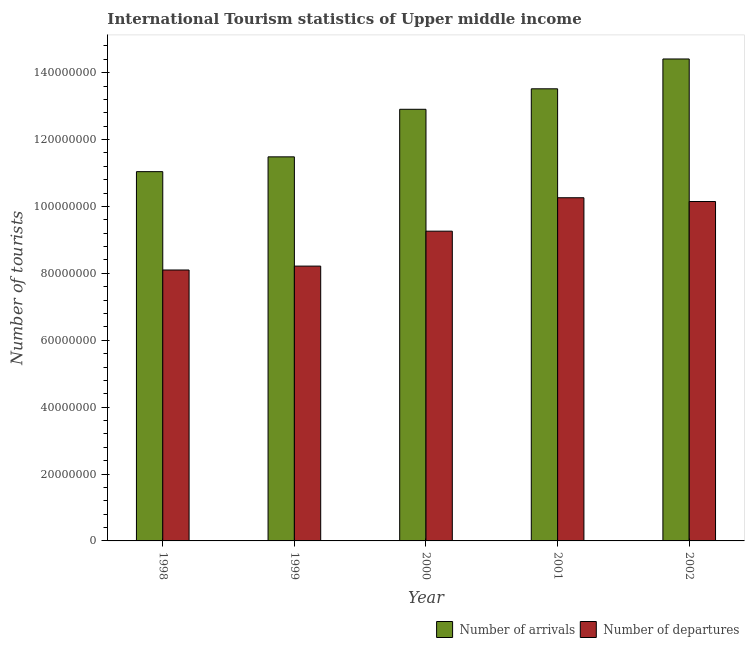How many groups of bars are there?
Keep it short and to the point. 5. Are the number of bars per tick equal to the number of legend labels?
Give a very brief answer. Yes. How many bars are there on the 5th tick from the right?
Ensure brevity in your answer.  2. What is the label of the 3rd group of bars from the left?
Give a very brief answer. 2000. What is the number of tourist departures in 2001?
Keep it short and to the point. 1.03e+08. Across all years, what is the maximum number of tourist departures?
Give a very brief answer. 1.03e+08. Across all years, what is the minimum number of tourist departures?
Provide a succinct answer. 8.10e+07. In which year was the number of tourist arrivals minimum?
Give a very brief answer. 1998. What is the total number of tourist arrivals in the graph?
Your answer should be very brief. 6.34e+08. What is the difference between the number of tourist departures in 2000 and that in 2001?
Give a very brief answer. -9.99e+06. What is the difference between the number of tourist arrivals in 2000 and the number of tourist departures in 2001?
Provide a short and direct response. -6.12e+06. What is the average number of tourist arrivals per year?
Offer a very short reply. 1.27e+08. In the year 2002, what is the difference between the number of tourist arrivals and number of tourist departures?
Ensure brevity in your answer.  0. In how many years, is the number of tourist arrivals greater than 44000000?
Give a very brief answer. 5. What is the ratio of the number of tourist arrivals in 1999 to that in 2000?
Make the answer very short. 0.89. Is the number of tourist arrivals in 2000 less than that in 2001?
Your response must be concise. Yes. Is the difference between the number of tourist arrivals in 1998 and 1999 greater than the difference between the number of tourist departures in 1998 and 1999?
Provide a succinct answer. No. What is the difference between the highest and the second highest number of tourist arrivals?
Give a very brief answer. 8.92e+06. What is the difference between the highest and the lowest number of tourist arrivals?
Your answer should be compact. 3.37e+07. What does the 1st bar from the left in 2001 represents?
Ensure brevity in your answer.  Number of arrivals. What does the 2nd bar from the right in 2002 represents?
Your response must be concise. Number of arrivals. How many bars are there?
Ensure brevity in your answer.  10. Are the values on the major ticks of Y-axis written in scientific E-notation?
Offer a very short reply. No. Does the graph contain grids?
Offer a very short reply. No. Where does the legend appear in the graph?
Your response must be concise. Bottom right. How are the legend labels stacked?
Keep it short and to the point. Horizontal. What is the title of the graph?
Your answer should be very brief. International Tourism statistics of Upper middle income. What is the label or title of the X-axis?
Your answer should be very brief. Year. What is the label or title of the Y-axis?
Ensure brevity in your answer.  Number of tourists. What is the Number of tourists in Number of arrivals in 1998?
Ensure brevity in your answer.  1.10e+08. What is the Number of tourists in Number of departures in 1998?
Offer a very short reply. 8.10e+07. What is the Number of tourists in Number of arrivals in 1999?
Ensure brevity in your answer.  1.15e+08. What is the Number of tourists in Number of departures in 1999?
Provide a succinct answer. 8.22e+07. What is the Number of tourists of Number of arrivals in 2000?
Keep it short and to the point. 1.29e+08. What is the Number of tourists in Number of departures in 2000?
Ensure brevity in your answer.  9.26e+07. What is the Number of tourists of Number of arrivals in 2001?
Make the answer very short. 1.35e+08. What is the Number of tourists in Number of departures in 2001?
Make the answer very short. 1.03e+08. What is the Number of tourists of Number of arrivals in 2002?
Keep it short and to the point. 1.44e+08. What is the Number of tourists of Number of departures in 2002?
Offer a very short reply. 1.01e+08. Across all years, what is the maximum Number of tourists in Number of arrivals?
Give a very brief answer. 1.44e+08. Across all years, what is the maximum Number of tourists in Number of departures?
Keep it short and to the point. 1.03e+08. Across all years, what is the minimum Number of tourists in Number of arrivals?
Ensure brevity in your answer.  1.10e+08. Across all years, what is the minimum Number of tourists in Number of departures?
Offer a very short reply. 8.10e+07. What is the total Number of tourists of Number of arrivals in the graph?
Keep it short and to the point. 6.34e+08. What is the total Number of tourists in Number of departures in the graph?
Make the answer very short. 4.60e+08. What is the difference between the Number of tourists of Number of arrivals in 1998 and that in 1999?
Ensure brevity in your answer.  -4.42e+06. What is the difference between the Number of tourists in Number of departures in 1998 and that in 1999?
Your answer should be compact. -1.16e+06. What is the difference between the Number of tourists of Number of arrivals in 1998 and that in 2000?
Provide a short and direct response. -1.86e+07. What is the difference between the Number of tourists in Number of departures in 1998 and that in 2000?
Your answer should be compact. -1.16e+07. What is the difference between the Number of tourists in Number of arrivals in 1998 and that in 2001?
Make the answer very short. -2.48e+07. What is the difference between the Number of tourists in Number of departures in 1998 and that in 2001?
Your answer should be very brief. -2.16e+07. What is the difference between the Number of tourists in Number of arrivals in 1998 and that in 2002?
Your answer should be very brief. -3.37e+07. What is the difference between the Number of tourists of Number of departures in 1998 and that in 2002?
Provide a short and direct response. -2.05e+07. What is the difference between the Number of tourists in Number of arrivals in 1999 and that in 2000?
Offer a very short reply. -1.42e+07. What is the difference between the Number of tourists in Number of departures in 1999 and that in 2000?
Keep it short and to the point. -1.04e+07. What is the difference between the Number of tourists of Number of arrivals in 1999 and that in 2001?
Give a very brief answer. -2.03e+07. What is the difference between the Number of tourists of Number of departures in 1999 and that in 2001?
Offer a terse response. -2.04e+07. What is the difference between the Number of tourists of Number of arrivals in 1999 and that in 2002?
Provide a short and direct response. -2.93e+07. What is the difference between the Number of tourists in Number of departures in 1999 and that in 2002?
Give a very brief answer. -1.93e+07. What is the difference between the Number of tourists in Number of arrivals in 2000 and that in 2001?
Offer a terse response. -6.12e+06. What is the difference between the Number of tourists of Number of departures in 2000 and that in 2001?
Offer a terse response. -9.99e+06. What is the difference between the Number of tourists of Number of arrivals in 2000 and that in 2002?
Your answer should be compact. -1.50e+07. What is the difference between the Number of tourists of Number of departures in 2000 and that in 2002?
Your answer should be very brief. -8.87e+06. What is the difference between the Number of tourists in Number of arrivals in 2001 and that in 2002?
Make the answer very short. -8.92e+06. What is the difference between the Number of tourists in Number of departures in 2001 and that in 2002?
Ensure brevity in your answer.  1.13e+06. What is the difference between the Number of tourists in Number of arrivals in 1998 and the Number of tourists in Number of departures in 1999?
Ensure brevity in your answer.  2.82e+07. What is the difference between the Number of tourists of Number of arrivals in 1998 and the Number of tourists of Number of departures in 2000?
Keep it short and to the point. 1.78e+07. What is the difference between the Number of tourists in Number of arrivals in 1998 and the Number of tourists in Number of departures in 2001?
Provide a succinct answer. 7.80e+06. What is the difference between the Number of tourists in Number of arrivals in 1998 and the Number of tourists in Number of departures in 2002?
Your answer should be very brief. 8.93e+06. What is the difference between the Number of tourists in Number of arrivals in 1999 and the Number of tourists in Number of departures in 2000?
Your answer should be compact. 2.22e+07. What is the difference between the Number of tourists in Number of arrivals in 1999 and the Number of tourists in Number of departures in 2001?
Keep it short and to the point. 1.22e+07. What is the difference between the Number of tourists of Number of arrivals in 1999 and the Number of tourists of Number of departures in 2002?
Your answer should be compact. 1.34e+07. What is the difference between the Number of tourists in Number of arrivals in 2000 and the Number of tourists in Number of departures in 2001?
Provide a short and direct response. 2.64e+07. What is the difference between the Number of tourists in Number of arrivals in 2000 and the Number of tourists in Number of departures in 2002?
Keep it short and to the point. 2.76e+07. What is the difference between the Number of tourists in Number of arrivals in 2001 and the Number of tourists in Number of departures in 2002?
Provide a short and direct response. 3.37e+07. What is the average Number of tourists of Number of arrivals per year?
Your answer should be compact. 1.27e+08. What is the average Number of tourists of Number of departures per year?
Your answer should be very brief. 9.20e+07. In the year 1998, what is the difference between the Number of tourists of Number of arrivals and Number of tourists of Number of departures?
Your answer should be compact. 2.94e+07. In the year 1999, what is the difference between the Number of tourists of Number of arrivals and Number of tourists of Number of departures?
Make the answer very short. 3.27e+07. In the year 2000, what is the difference between the Number of tourists of Number of arrivals and Number of tourists of Number of departures?
Make the answer very short. 3.64e+07. In the year 2001, what is the difference between the Number of tourists in Number of arrivals and Number of tourists in Number of departures?
Provide a short and direct response. 3.26e+07. In the year 2002, what is the difference between the Number of tourists of Number of arrivals and Number of tourists of Number of departures?
Give a very brief answer. 4.26e+07. What is the ratio of the Number of tourists in Number of arrivals in 1998 to that in 1999?
Give a very brief answer. 0.96. What is the ratio of the Number of tourists in Number of departures in 1998 to that in 1999?
Your answer should be compact. 0.99. What is the ratio of the Number of tourists in Number of arrivals in 1998 to that in 2000?
Offer a terse response. 0.86. What is the ratio of the Number of tourists of Number of departures in 1998 to that in 2000?
Your answer should be very brief. 0.87. What is the ratio of the Number of tourists in Number of arrivals in 1998 to that in 2001?
Offer a terse response. 0.82. What is the ratio of the Number of tourists of Number of departures in 1998 to that in 2001?
Provide a succinct answer. 0.79. What is the ratio of the Number of tourists of Number of arrivals in 1998 to that in 2002?
Keep it short and to the point. 0.77. What is the ratio of the Number of tourists in Number of departures in 1998 to that in 2002?
Offer a terse response. 0.8. What is the ratio of the Number of tourists of Number of arrivals in 1999 to that in 2000?
Make the answer very short. 0.89. What is the ratio of the Number of tourists in Number of departures in 1999 to that in 2000?
Offer a very short reply. 0.89. What is the ratio of the Number of tourists in Number of arrivals in 1999 to that in 2001?
Offer a very short reply. 0.85. What is the ratio of the Number of tourists in Number of departures in 1999 to that in 2001?
Keep it short and to the point. 0.8. What is the ratio of the Number of tourists of Number of arrivals in 1999 to that in 2002?
Offer a terse response. 0.8. What is the ratio of the Number of tourists in Number of departures in 1999 to that in 2002?
Provide a short and direct response. 0.81. What is the ratio of the Number of tourists of Number of arrivals in 2000 to that in 2001?
Your answer should be very brief. 0.95. What is the ratio of the Number of tourists of Number of departures in 2000 to that in 2001?
Your answer should be compact. 0.9. What is the ratio of the Number of tourists of Number of arrivals in 2000 to that in 2002?
Give a very brief answer. 0.9. What is the ratio of the Number of tourists of Number of departures in 2000 to that in 2002?
Ensure brevity in your answer.  0.91. What is the ratio of the Number of tourists of Number of arrivals in 2001 to that in 2002?
Keep it short and to the point. 0.94. What is the ratio of the Number of tourists of Number of departures in 2001 to that in 2002?
Ensure brevity in your answer.  1.01. What is the difference between the highest and the second highest Number of tourists in Number of arrivals?
Offer a terse response. 8.92e+06. What is the difference between the highest and the second highest Number of tourists in Number of departures?
Provide a succinct answer. 1.13e+06. What is the difference between the highest and the lowest Number of tourists in Number of arrivals?
Ensure brevity in your answer.  3.37e+07. What is the difference between the highest and the lowest Number of tourists in Number of departures?
Give a very brief answer. 2.16e+07. 